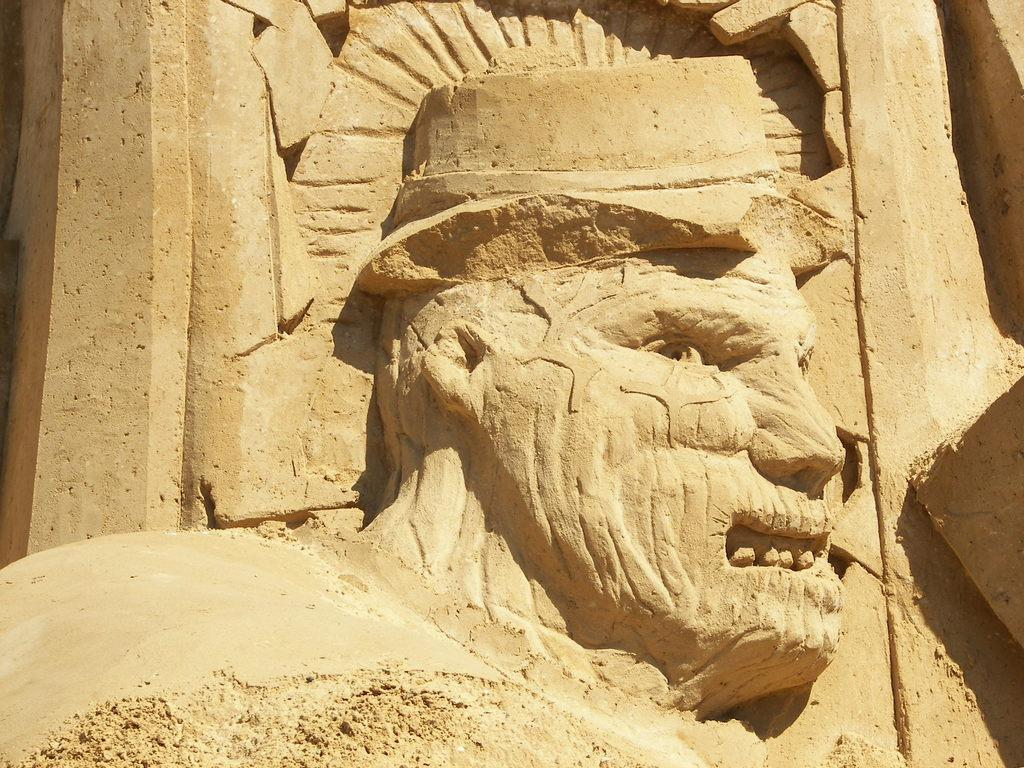What is the main subject of the image? The main subject of the image is a sculpture of a person. Can you describe the color of the sculpture? The sculpture is light brown in color. What type of cream is being used to create the sculpture in the image? There is no indication in the image that cream is being used to create the sculpture. 